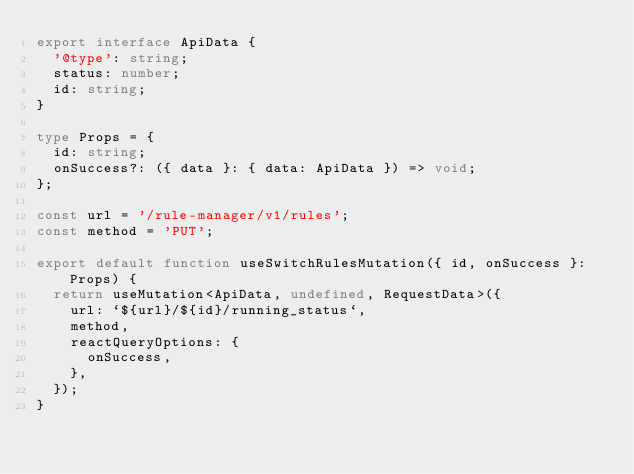<code> <loc_0><loc_0><loc_500><loc_500><_TypeScript_>export interface ApiData {
  '@type': string;
  status: number;
  id: string;
}

type Props = {
  id: string;
  onSuccess?: ({ data }: { data: ApiData }) => void;
};

const url = '/rule-manager/v1/rules';
const method = 'PUT';

export default function useSwitchRulesMutation({ id, onSuccess }: Props) {
  return useMutation<ApiData, undefined, RequestData>({
    url: `${url}/${id}/running_status`,
    method,
    reactQueryOptions: {
      onSuccess,
    },
  });
}
</code> 